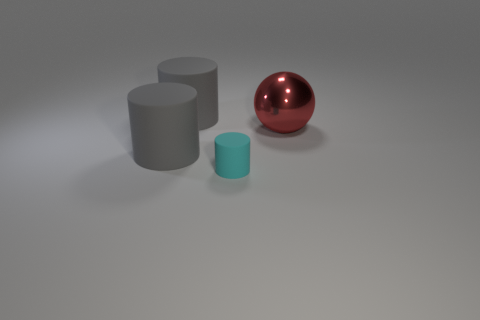What can you infer about the material of the objects? The materials of the objects appear to be different. The red sphere has a reflective surface suggesting a material like polished metal or plastic, while both cylinders have a more matte finish. The grey cylinder might be made from a material like stone or dull metal, and the cyan cylinder has a slightly shiner finish, possibly indicating a rubber or plastic material.  And what about their textures? The textures are not highly detailed in this image, but the objects appear smooth. The red sphere has a flawless, reflective surface that suggests a highly smooth texture, and the cylinders also seem to have uniformly smooth surfaces. 